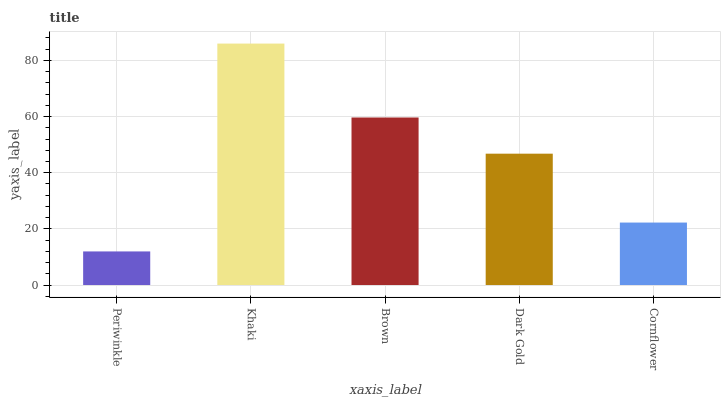Is Periwinkle the minimum?
Answer yes or no. Yes. Is Khaki the maximum?
Answer yes or no. Yes. Is Brown the minimum?
Answer yes or no. No. Is Brown the maximum?
Answer yes or no. No. Is Khaki greater than Brown?
Answer yes or no. Yes. Is Brown less than Khaki?
Answer yes or no. Yes. Is Brown greater than Khaki?
Answer yes or no. No. Is Khaki less than Brown?
Answer yes or no. No. Is Dark Gold the high median?
Answer yes or no. Yes. Is Dark Gold the low median?
Answer yes or no. Yes. Is Periwinkle the high median?
Answer yes or no. No. Is Periwinkle the low median?
Answer yes or no. No. 